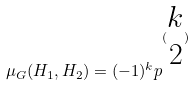<formula> <loc_0><loc_0><loc_500><loc_500>\mu _ { G } ( H _ { 1 } , H _ { 2 } ) = ( - 1 ) ^ { k } p ^ { ( \begin{matrix} k \\ 2 \end{matrix} ) }</formula> 